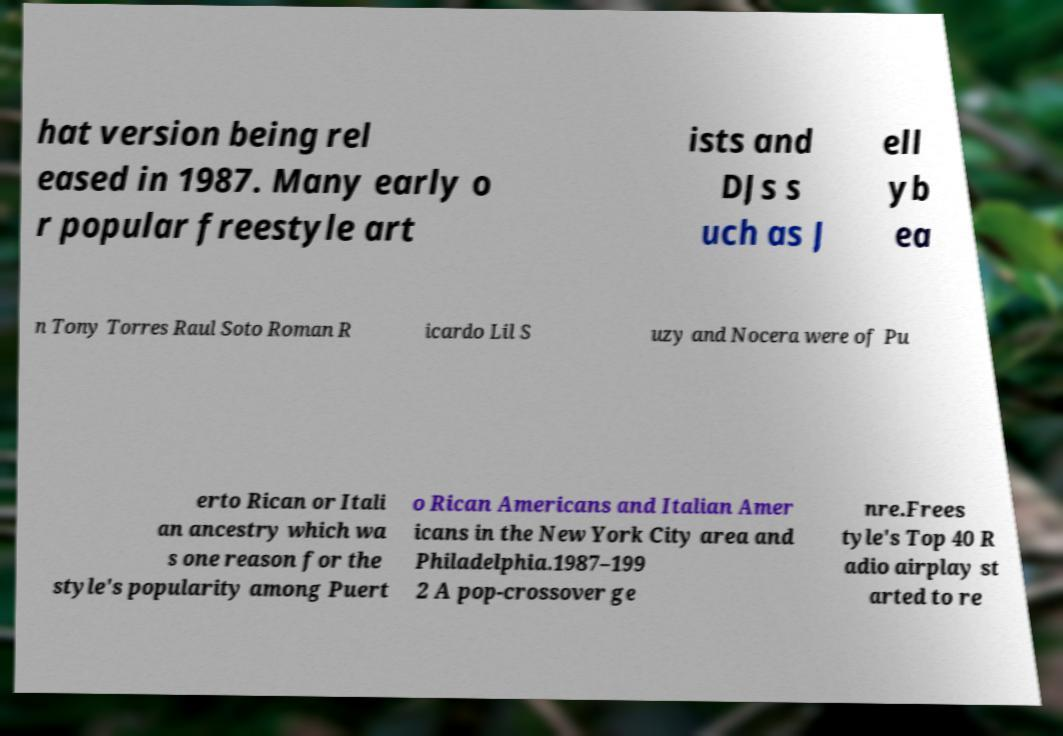Could you extract and type out the text from this image? hat version being rel eased in 1987. Many early o r popular freestyle art ists and DJs s uch as J ell yb ea n Tony Torres Raul Soto Roman R icardo Lil S uzy and Nocera were of Pu erto Rican or Itali an ancestry which wa s one reason for the style's popularity among Puert o Rican Americans and Italian Amer icans in the New York City area and Philadelphia.1987–199 2 A pop-crossover ge nre.Frees tyle's Top 40 R adio airplay st arted to re 